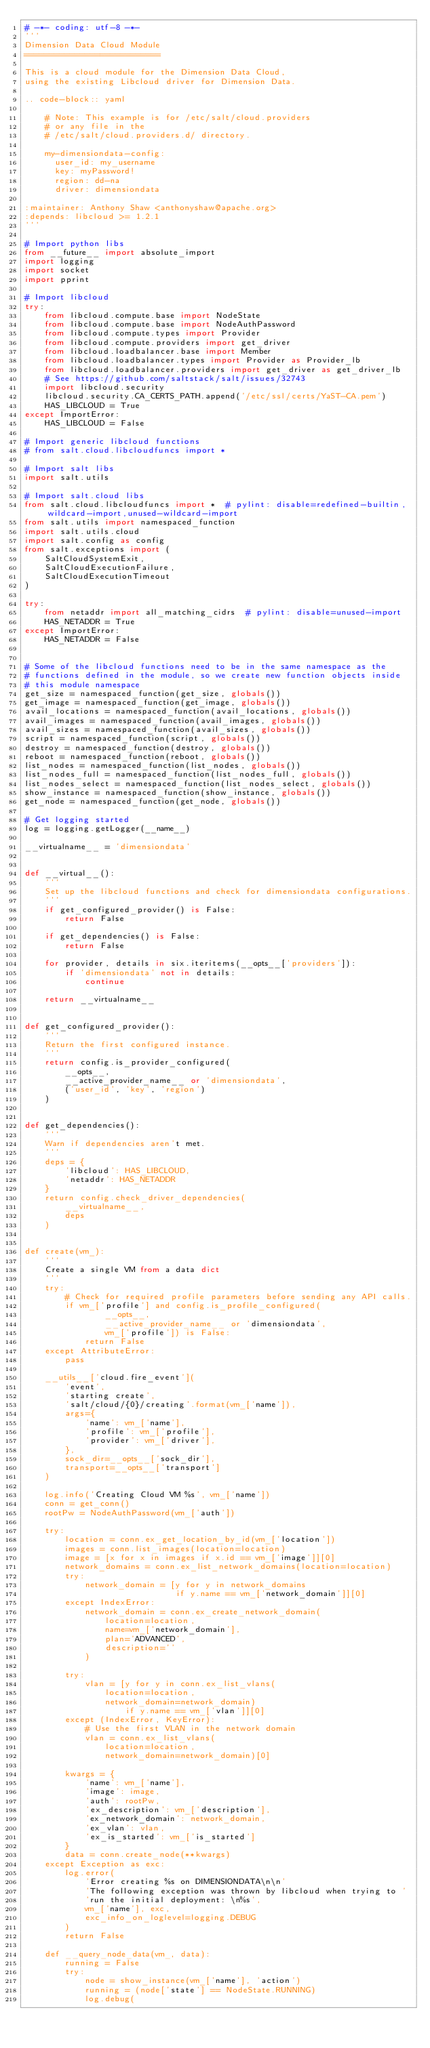Convert code to text. <code><loc_0><loc_0><loc_500><loc_500><_Python_># -*- coding: utf-8 -*-
'''
Dimension Data Cloud Module
===========================

This is a cloud module for the Dimension Data Cloud,
using the existing Libcloud driver for Dimension Data.

.. code-block:: yaml

    # Note: This example is for /etc/salt/cloud.providers
    # or any file in the
    # /etc/salt/cloud.providers.d/ directory.

    my-dimensiondata-config:
      user_id: my_username
      key: myPassword!
      region: dd-na
      driver: dimensiondata

:maintainer: Anthony Shaw <anthonyshaw@apache.org>
:depends: libcloud >= 1.2.1
'''

# Import python libs
from __future__ import absolute_import
import logging
import socket
import pprint

# Import libcloud
try:
    from libcloud.compute.base import NodeState
    from libcloud.compute.base import NodeAuthPassword
    from libcloud.compute.types import Provider
    from libcloud.compute.providers import get_driver
    from libcloud.loadbalancer.base import Member
    from libcloud.loadbalancer.types import Provider as Provider_lb
    from libcloud.loadbalancer.providers import get_driver as get_driver_lb
    # See https://github.com/saltstack/salt/issues/32743
    import libcloud.security
    libcloud.security.CA_CERTS_PATH.append('/etc/ssl/certs/YaST-CA.pem')
    HAS_LIBCLOUD = True
except ImportError:
    HAS_LIBCLOUD = False

# Import generic libcloud functions
# from salt.cloud.libcloudfuncs import *

# Import salt libs
import salt.utils

# Import salt.cloud libs
from salt.cloud.libcloudfuncs import *  # pylint: disable=redefined-builtin,wildcard-import,unused-wildcard-import
from salt.utils import namespaced_function
import salt.utils.cloud
import salt.config as config
from salt.exceptions import (
    SaltCloudSystemExit,
    SaltCloudExecutionFailure,
    SaltCloudExecutionTimeout
)

try:
    from netaddr import all_matching_cidrs  # pylint: disable=unused-import
    HAS_NETADDR = True
except ImportError:
    HAS_NETADDR = False


# Some of the libcloud functions need to be in the same namespace as the
# functions defined in the module, so we create new function objects inside
# this module namespace
get_size = namespaced_function(get_size, globals())
get_image = namespaced_function(get_image, globals())
avail_locations = namespaced_function(avail_locations, globals())
avail_images = namespaced_function(avail_images, globals())
avail_sizes = namespaced_function(avail_sizes, globals())
script = namespaced_function(script, globals())
destroy = namespaced_function(destroy, globals())
reboot = namespaced_function(reboot, globals())
list_nodes = namespaced_function(list_nodes, globals())
list_nodes_full = namespaced_function(list_nodes_full, globals())
list_nodes_select = namespaced_function(list_nodes_select, globals())
show_instance = namespaced_function(show_instance, globals())
get_node = namespaced_function(get_node, globals())

# Get logging started
log = logging.getLogger(__name__)

__virtualname__ = 'dimensiondata'


def __virtual__():
    '''
    Set up the libcloud functions and check for dimensiondata configurations.
    '''
    if get_configured_provider() is False:
        return False

    if get_dependencies() is False:
        return False

    for provider, details in six.iteritems(__opts__['providers']):
        if 'dimensiondata' not in details:
            continue

    return __virtualname__


def get_configured_provider():
    '''
    Return the first configured instance.
    '''
    return config.is_provider_configured(
        __opts__,
        __active_provider_name__ or 'dimensiondata',
        ('user_id', 'key', 'region')
    )


def get_dependencies():
    '''
    Warn if dependencies aren't met.
    '''
    deps = {
        'libcloud': HAS_LIBCLOUD,
        'netaddr': HAS_NETADDR
    }
    return config.check_driver_dependencies(
        __virtualname__,
        deps
    )


def create(vm_):
    '''
    Create a single VM from a data dict
    '''
    try:
        # Check for required profile parameters before sending any API calls.
        if vm_['profile'] and config.is_profile_configured(
                __opts__,
                __active_provider_name__ or 'dimensiondata',
                vm_['profile']) is False:
            return False
    except AttributeError:
        pass

    __utils__['cloud.fire_event'](
        'event',
        'starting create',
        'salt/cloud/{0}/creating'.format(vm_['name']),
        args={
            'name': vm_['name'],
            'profile': vm_['profile'],
            'provider': vm_['driver'],
        },
        sock_dir=__opts__['sock_dir'],
        transport=__opts__['transport']
    )

    log.info('Creating Cloud VM %s', vm_['name'])
    conn = get_conn()
    rootPw = NodeAuthPassword(vm_['auth'])

    try:
        location = conn.ex_get_location_by_id(vm_['location'])
        images = conn.list_images(location=location)
        image = [x for x in images if x.id == vm_['image']][0]
        network_domains = conn.ex_list_network_domains(location=location)
        try:
            network_domain = [y for y in network_domains
                              if y.name == vm_['network_domain']][0]
        except IndexError:
            network_domain = conn.ex_create_network_domain(
                location=location,
                name=vm_['network_domain'],
                plan='ADVANCED',
                description=''
            )

        try:
            vlan = [y for y in conn.ex_list_vlans(
                location=location,
                network_domain=network_domain)
                    if y.name == vm_['vlan']][0]
        except (IndexError, KeyError):
            # Use the first VLAN in the network domain
            vlan = conn.ex_list_vlans(
                location=location,
                network_domain=network_domain)[0]

        kwargs = {
            'name': vm_['name'],
            'image': image,
            'auth': rootPw,
            'ex_description': vm_['description'],
            'ex_network_domain': network_domain,
            'ex_vlan': vlan,
            'ex_is_started': vm_['is_started']
        }
        data = conn.create_node(**kwargs)
    except Exception as exc:
        log.error(
            'Error creating %s on DIMENSIONDATA\n\n'
            'The following exception was thrown by libcloud when trying to '
            'run the initial deployment: \n%s',
            vm_['name'], exc,
            exc_info_on_loglevel=logging.DEBUG
        )
        return False

    def __query_node_data(vm_, data):
        running = False
        try:
            node = show_instance(vm_['name'], 'action')
            running = (node['state'] == NodeState.RUNNING)
            log.debug(</code> 